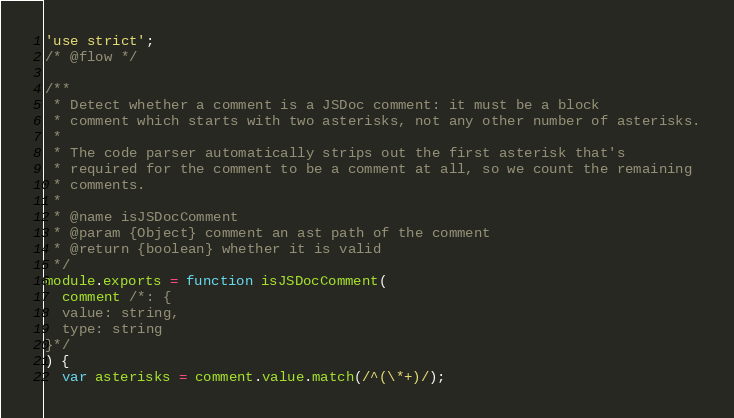Convert code to text. <code><loc_0><loc_0><loc_500><loc_500><_JavaScript_>'use strict';
/* @flow */

/**
 * Detect whether a comment is a JSDoc comment: it must be a block
 * comment which starts with two asterisks, not any other number of asterisks.
 *
 * The code parser automatically strips out the first asterisk that's
 * required for the comment to be a comment at all, so we count the remaining
 * comments.
 *
 * @name isJSDocComment
 * @param {Object} comment an ast path of the comment
 * @return {boolean} whether it is valid
 */
module.exports = function isJSDocComment(
  comment /*: {
  value: string,
  type: string
}*/
) {
  var asterisks = comment.value.match(/^(\*+)/);</code> 